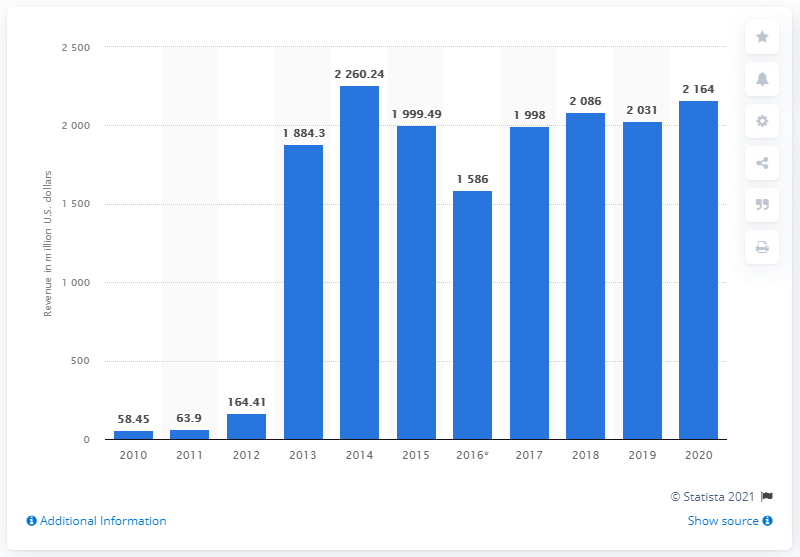Indicate a few pertinent items in this graphic. In the year 2020, the revenue of King in the United States was approximately 2164. 